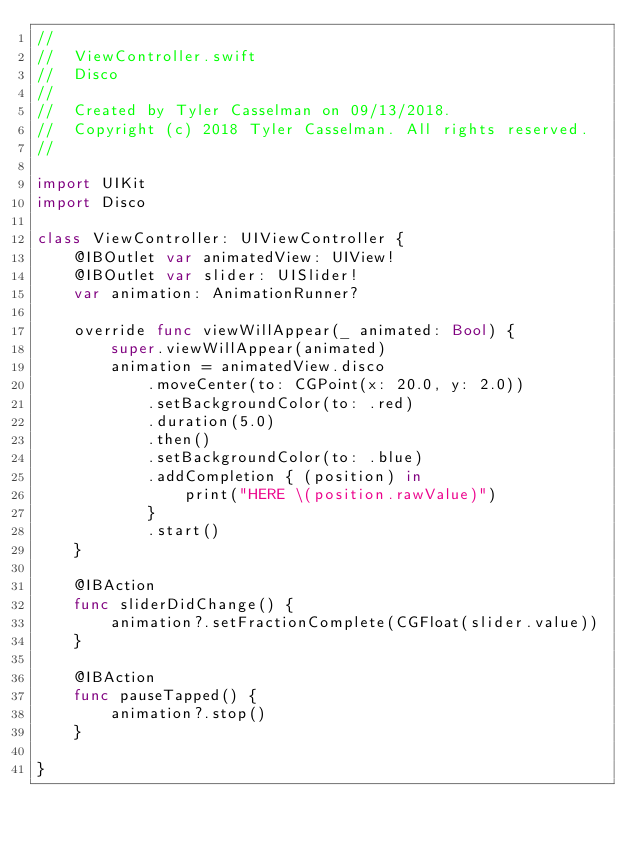Convert code to text. <code><loc_0><loc_0><loc_500><loc_500><_Swift_>//
//  ViewController.swift
//  Disco
//
//  Created by Tyler Casselman on 09/13/2018.
//  Copyright (c) 2018 Tyler Casselman. All rights reserved.
//

import UIKit
import Disco

class ViewController: UIViewController {
    @IBOutlet var animatedView: UIView!
    @IBOutlet var slider: UISlider!
    var animation: AnimationRunner?

    override func viewWillAppear(_ animated: Bool) {
        super.viewWillAppear(animated)
        animation = animatedView.disco
            .moveCenter(to: CGPoint(x: 20.0, y: 2.0))
            .setBackgroundColor(to: .red)
            .duration(5.0)
            .then()
            .setBackgroundColor(to: .blue)
            .addCompletion { (position) in
                print("HERE \(position.rawValue)")
            }
            .start()
    }
    
    @IBAction
    func sliderDidChange() {
        animation?.setFractionComplete(CGFloat(slider.value))
    }
    
    @IBAction
    func pauseTapped() {
        animation?.stop()
    }

}

</code> 